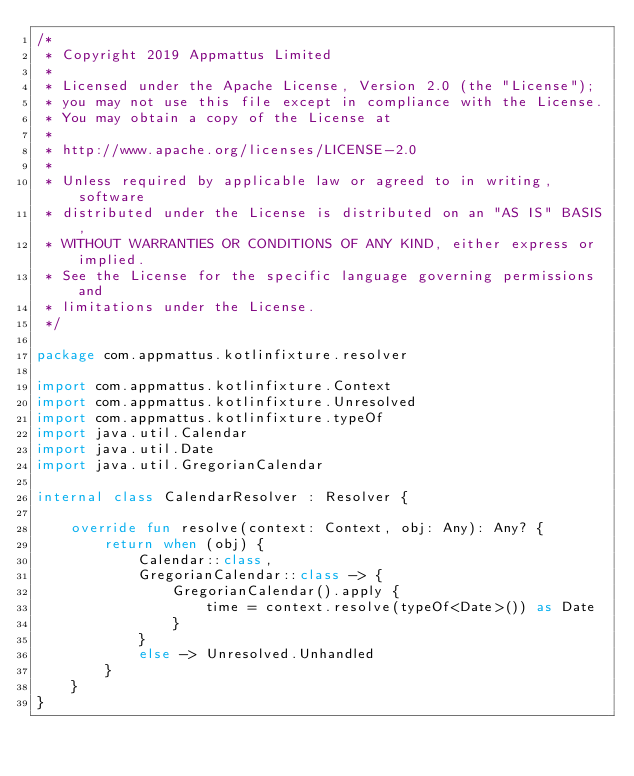<code> <loc_0><loc_0><loc_500><loc_500><_Kotlin_>/*
 * Copyright 2019 Appmattus Limited
 *
 * Licensed under the Apache License, Version 2.0 (the "License");
 * you may not use this file except in compliance with the License.
 * You may obtain a copy of the License at
 *
 * http://www.apache.org/licenses/LICENSE-2.0
 *
 * Unless required by applicable law or agreed to in writing, software
 * distributed under the License is distributed on an "AS IS" BASIS,
 * WITHOUT WARRANTIES OR CONDITIONS OF ANY KIND, either express or implied.
 * See the License for the specific language governing permissions and
 * limitations under the License.
 */

package com.appmattus.kotlinfixture.resolver

import com.appmattus.kotlinfixture.Context
import com.appmattus.kotlinfixture.Unresolved
import com.appmattus.kotlinfixture.typeOf
import java.util.Calendar
import java.util.Date
import java.util.GregorianCalendar

internal class CalendarResolver : Resolver {

    override fun resolve(context: Context, obj: Any): Any? {
        return when (obj) {
            Calendar::class,
            GregorianCalendar::class -> {
                GregorianCalendar().apply {
                    time = context.resolve(typeOf<Date>()) as Date
                }
            }
            else -> Unresolved.Unhandled
        }
    }
}
</code> 